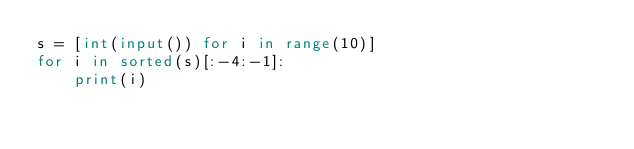Convert code to text. <code><loc_0><loc_0><loc_500><loc_500><_Python_>s = [int(input()) for i in range(10)]
for i in sorted(s)[:-4:-1]:
    print(i)</code> 